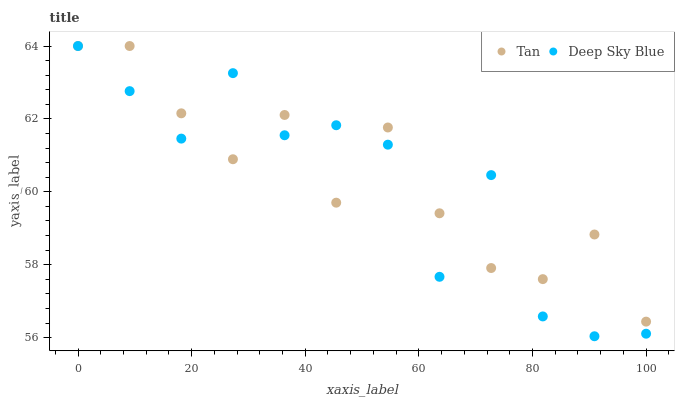Does Deep Sky Blue have the minimum area under the curve?
Answer yes or no. Yes. Does Tan have the maximum area under the curve?
Answer yes or no. Yes. Does Deep Sky Blue have the maximum area under the curve?
Answer yes or no. No. Is Tan the smoothest?
Answer yes or no. Yes. Is Deep Sky Blue the roughest?
Answer yes or no. Yes. Is Deep Sky Blue the smoothest?
Answer yes or no. No. Does Deep Sky Blue have the lowest value?
Answer yes or no. Yes. Does Deep Sky Blue have the highest value?
Answer yes or no. Yes. Does Tan intersect Deep Sky Blue?
Answer yes or no. Yes. Is Tan less than Deep Sky Blue?
Answer yes or no. No. Is Tan greater than Deep Sky Blue?
Answer yes or no. No. 